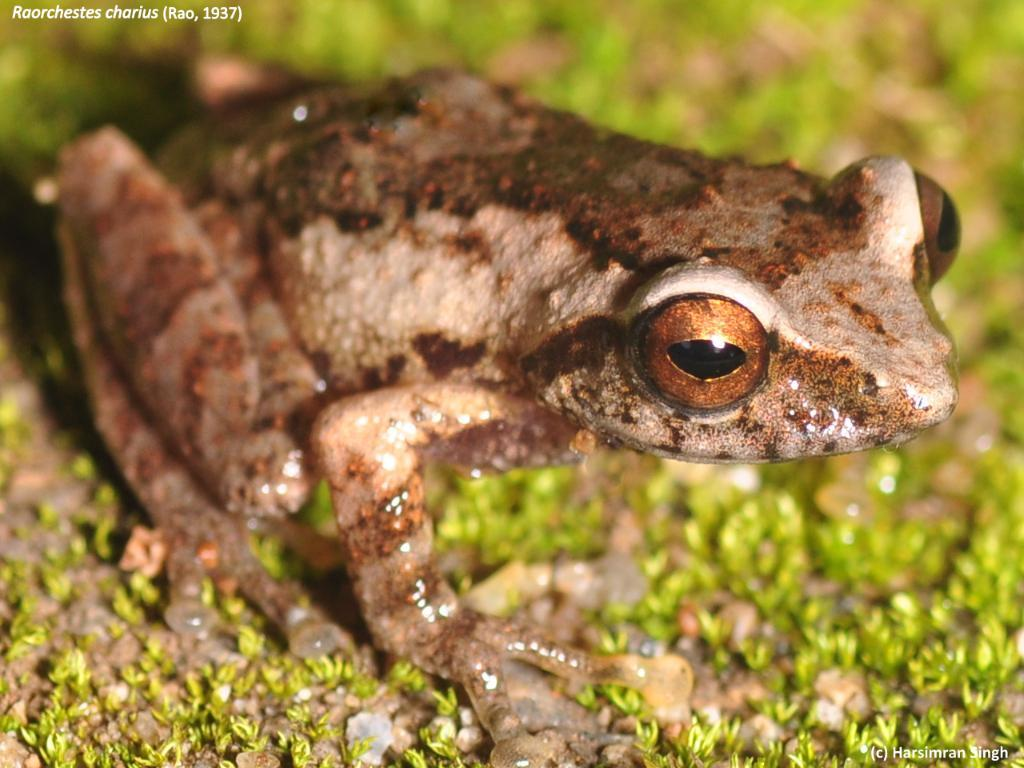What type of surface is visible in the image? There is ground visible in the image. What kind of vegetation is present on the ground? There is grass on the ground. What animal can be seen in the image? There is a frog in the image. What colors are present on the frog? The frog is cream, brown, and black in color. What is the tendency of the stick to bend in the image? There is no stick present in the image, so it is not possible to determine its tendency to bend. 